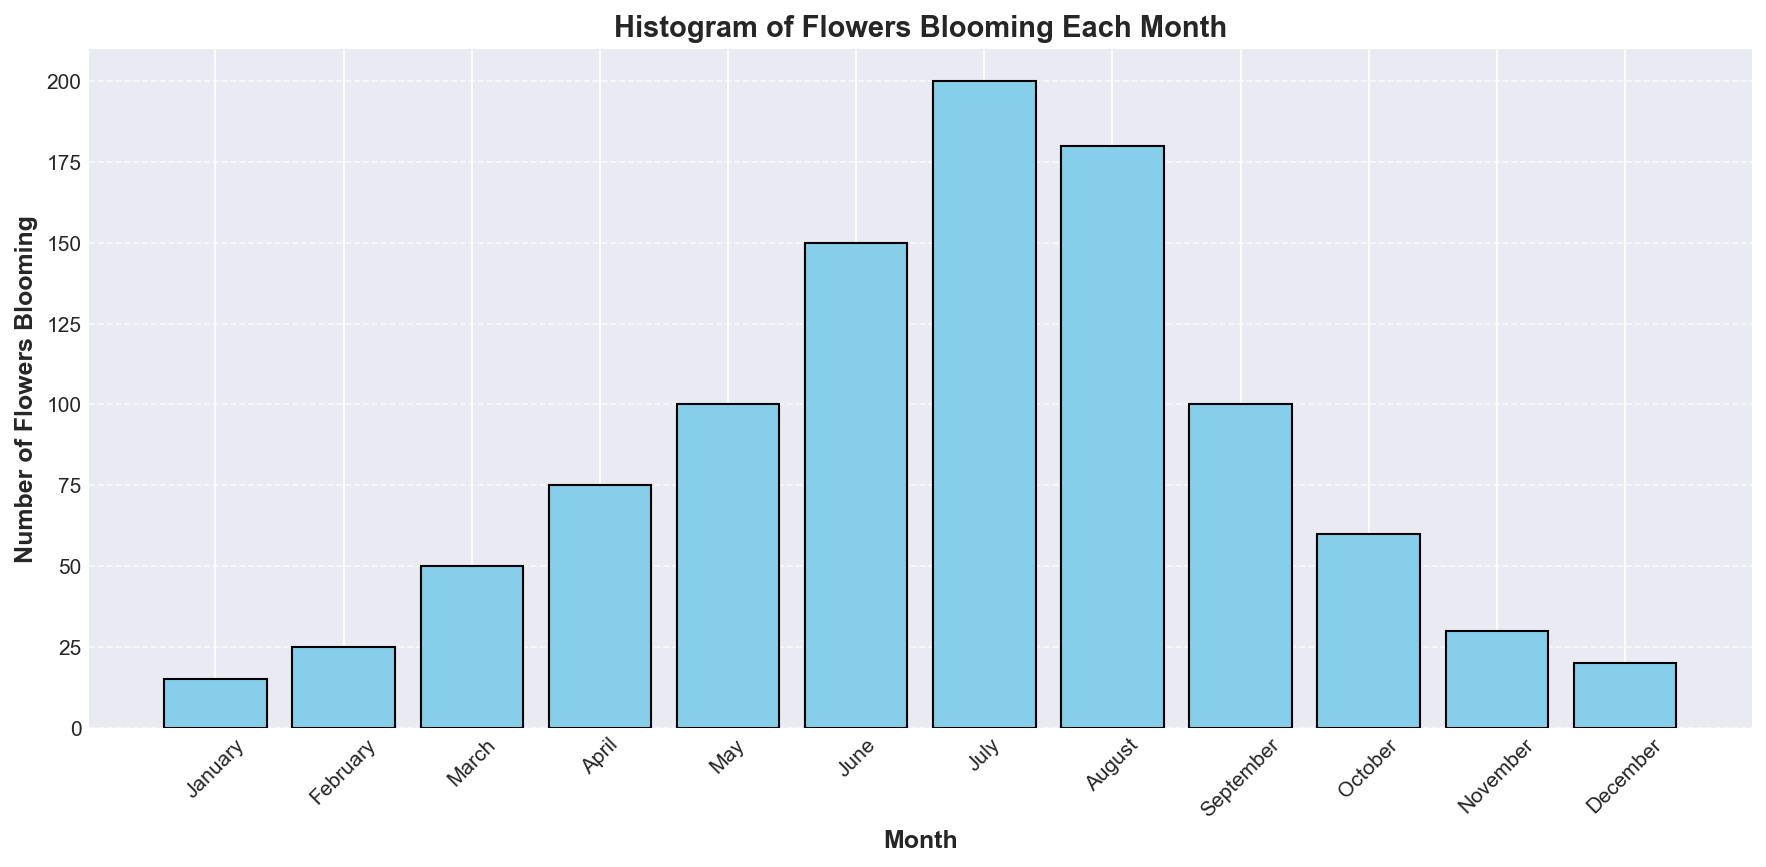What's the month with the highest number of flowers blooming? The month with the tallest bar represents the highest number of flowers blooming. By looking at the heights, July has the tallest bar which indicates 200 flowers blooming.
Answer: July What is the combined number of flowers blooming in January, February, and March? To find the combined number of flowers blooming, add the values of January, February, and March: 15 (January) + 25 (February) + 50 (March) = 90.
Answer: 90 Which month has fewer flowers blooming, November or December? Compare the heights of the bars for November and December. November has 30 flowers blooming, and December has 20 flowers blooming. Therefore, December has fewer flowers.
Answer: December What's the average number of flowers blooming from April to June? First, sum the number of flowers blooming from April to June: 75 (April) + 100 (May) + 150 (June) = 325. Then divide by the number of months: 325 / 3 = approximately 108.33.
Answer: 108.33 Which months have over 100 flowers blooming? Identify the bars with heights over 100. These correspond to June (150), July (200), and August (180).
Answer: June, July, August By how much does the number of flowers blooming in May differ from the number in September? Subtract the number of flowers blooming in September from that of May: 100 (May) - 100 (September) = 0.
Answer: 0 What is the total number of flowers blooming from January to December? Sum the number of flowers blooming for each month: 15 + 25 + 50 + 75 + 100 + 150 + 200 + 180 + 100 + 60 + 30 + 20 = 1005.
Answer: 1005 In which month do flowers start blooming at a rate higher than 50 per month for the first time? Identify the first month where the bar height is greater than 50. This is April with 75 flowers blooming.
Answer: April How many more flowers bloomed in June compared to March? Subtract the number of flowers blooming in March from June: 150 (June) - 50 (March) = 100.
Answer: 100 